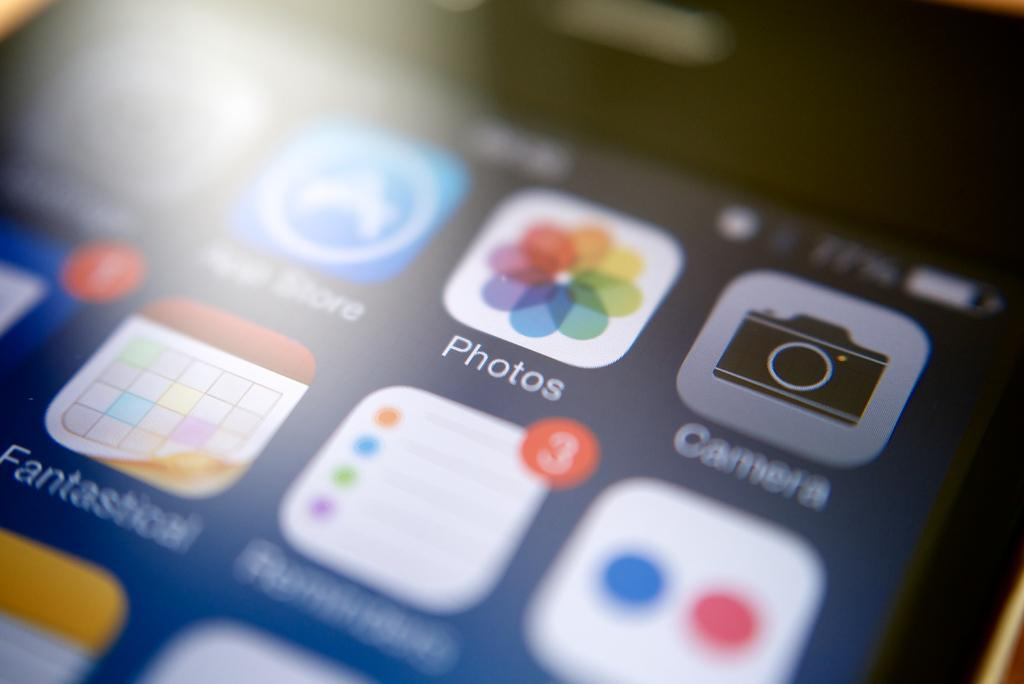What electronic device is visible in the image? There is a mobile phone in the image. What can be seen on the screen of the mobile phone? The mobile phone has application icons on it. What type of grass is growing on the mobile phone in the image? There is no grass present on the mobile phone in the image. How can the person in the image be helped with their mobile phone? The image does not show a person or any indication of needing help with the mobile phone. 